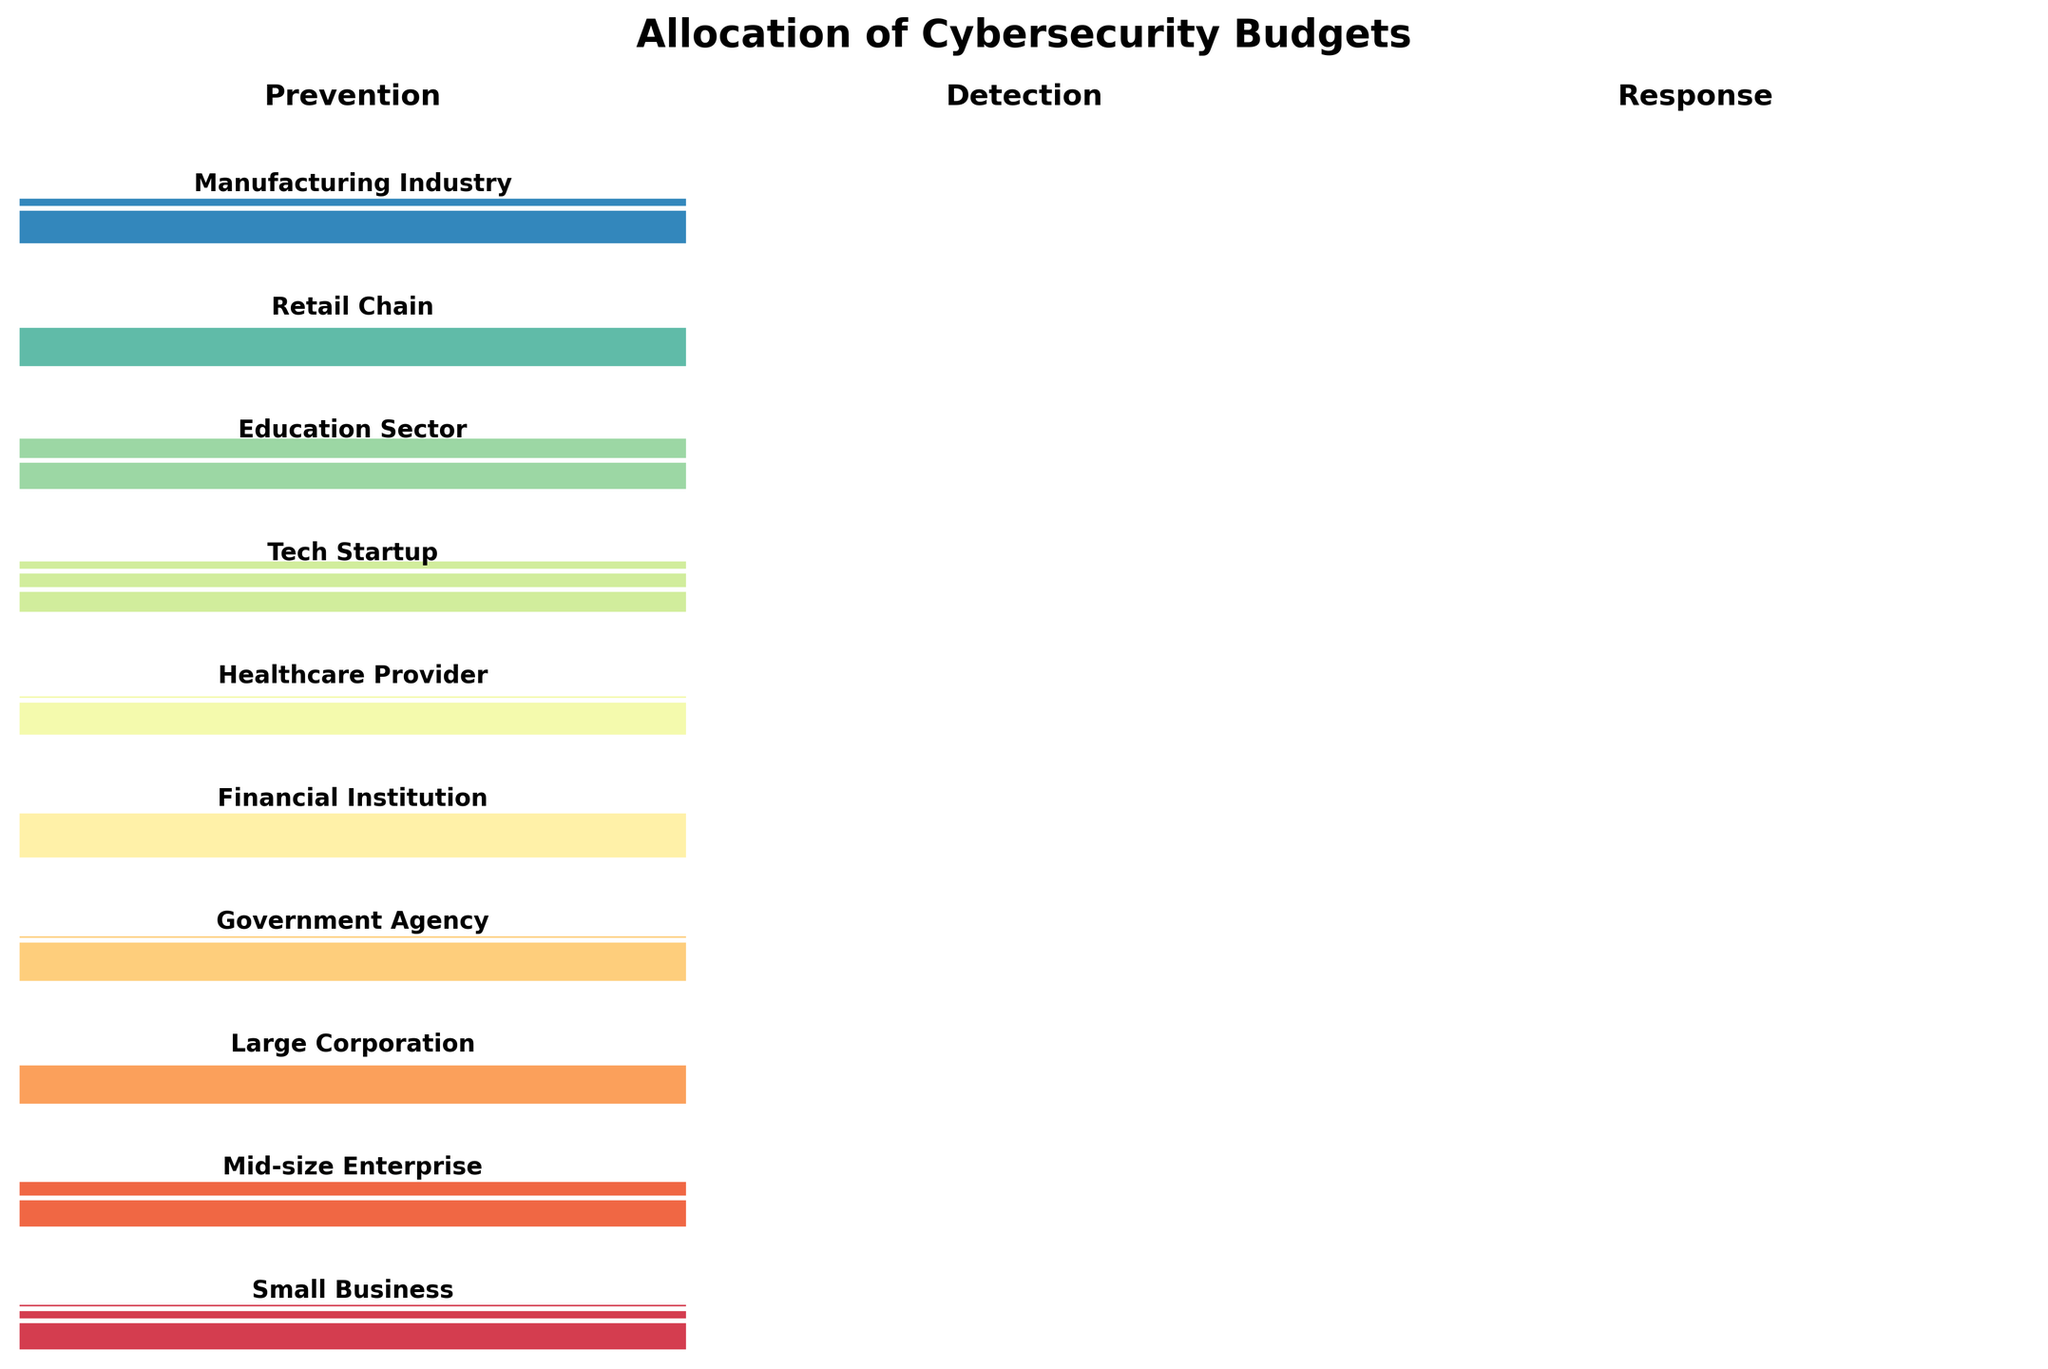What's the title of the plot? The title is located at the top of the figure, usually near the center. It provides a summary of what the plot represents.
Answer: Allocation of Cybersecurity Budgets How is the budget allocated for a Tech Startup? Locate the segment for "Tech Startup" in the plot, and identify the proportions for Prevention, Detection, and Response.
Answer: 45% Prevention, 35% Detection, 20% Response Which organization allocates the highest percentage to Response? Look for the segment corresponding to each organization and compare the height for Response.
Answer: Financial Institution How does the Prevention budget for a Manufacturing Industry compare to that of a Financial Institution? Locate the Prevention segments for both organizations and compare their relative sizes.
Answer: Manufacturing Industry allocates more to Prevention Which category has the highest average allocation across all organizations? Calculate the average allocation for Prevention, Detection, and Response by summing their respective values across all organizations and dividing by the number of organizations. The highest average is determined.
Answer: Detection Is there any organization that allocates an equal percentage to Detection and Response? Examine the plot for segments where the Detection and Response columns have equal heights for a single organization.
Answer: Large Corporation and Government Agency What's the difference in the Response budget between a Healthcare Provider and a Retail Chain? Compare the Response segments for both organizations and subtract the smaller value from the larger one.
Answer: 5% Which organization allocates the least to Prevention? Identify the segments for all organizations in the Prevention column and find the one with the smallest height.
Answer: Government Agency Among the given organizations, who has the most balanced budget allocation across the three categories? A balanced budget means each category has similar heights. Locate the organization whose Prevention, Detection, and Response segments are closest in size.
Answer: Mid-size Enterprise 